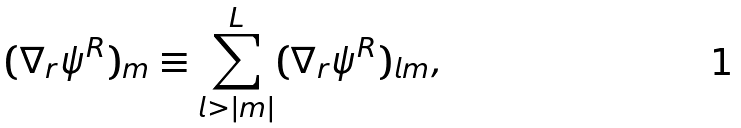Convert formula to latex. <formula><loc_0><loc_0><loc_500><loc_500>( \nabla _ { r } \psi ^ { R } ) _ { m } \equiv \sum _ { l > | m | } ^ { L } ( \nabla _ { r } \psi ^ { R } ) _ { l m } ,</formula> 